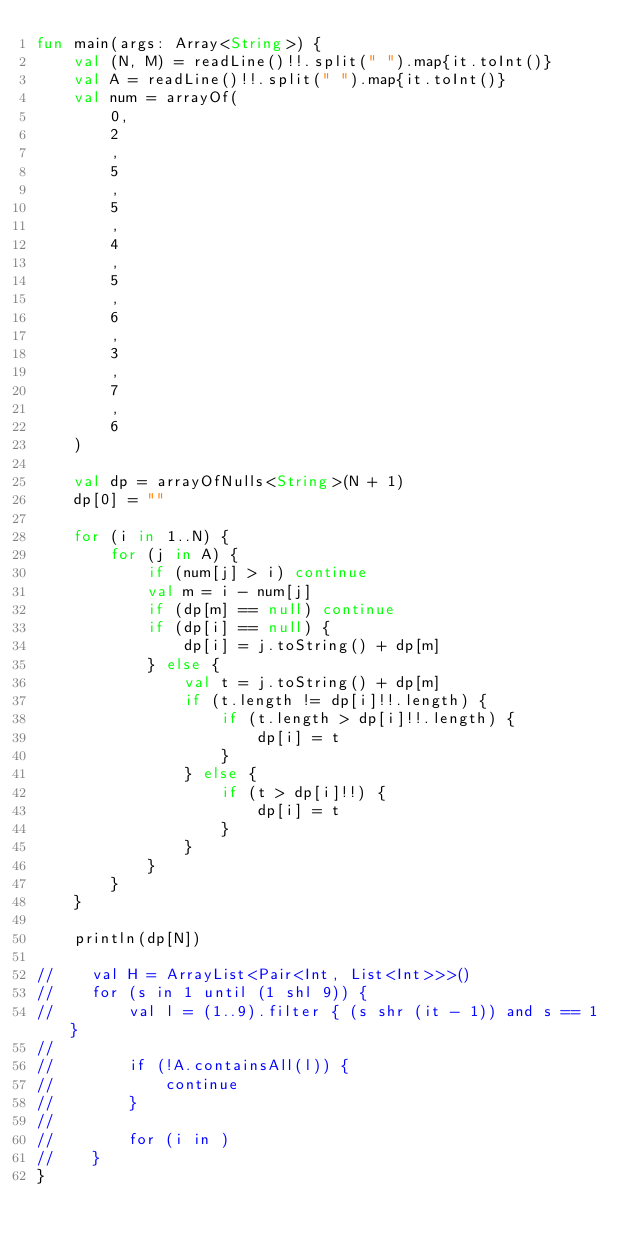Convert code to text. <code><loc_0><loc_0><loc_500><loc_500><_Kotlin_>fun main(args: Array<String>) {
    val (N, M) = readLine()!!.split(" ").map{it.toInt()}
    val A = readLine()!!.split(" ").map{it.toInt()}
    val num = arrayOf(
        0,
        2
        ,
        5
        ,
        5
        ,
        4
        ,
        5
        ,
        6
        ,
        3
        ,
        7
        ,
        6
    )

    val dp = arrayOfNulls<String>(N + 1)
    dp[0] = ""

    for (i in 1..N) {
        for (j in A) {
            if (num[j] > i) continue
            val m = i - num[j]
            if (dp[m] == null) continue
            if (dp[i] == null) {
                dp[i] = j.toString() + dp[m]
            } else {
                val t = j.toString() + dp[m]
                if (t.length != dp[i]!!.length) {
                    if (t.length > dp[i]!!.length) {
                        dp[i] = t
                    }
                } else {
                    if (t > dp[i]!!) {
                        dp[i] = t
                    }
                }
            }
        }
    }

    println(dp[N])

//    val H = ArrayList<Pair<Int, List<Int>>>()
//    for (s in 1 until (1 shl 9)) {
//        val l = (1..9).filter { (s shr (it - 1)) and s == 1 }
//
//        if (!A.containsAll(l)) {
//            continue
//        }
//
//        for (i in )
//    }
}
</code> 